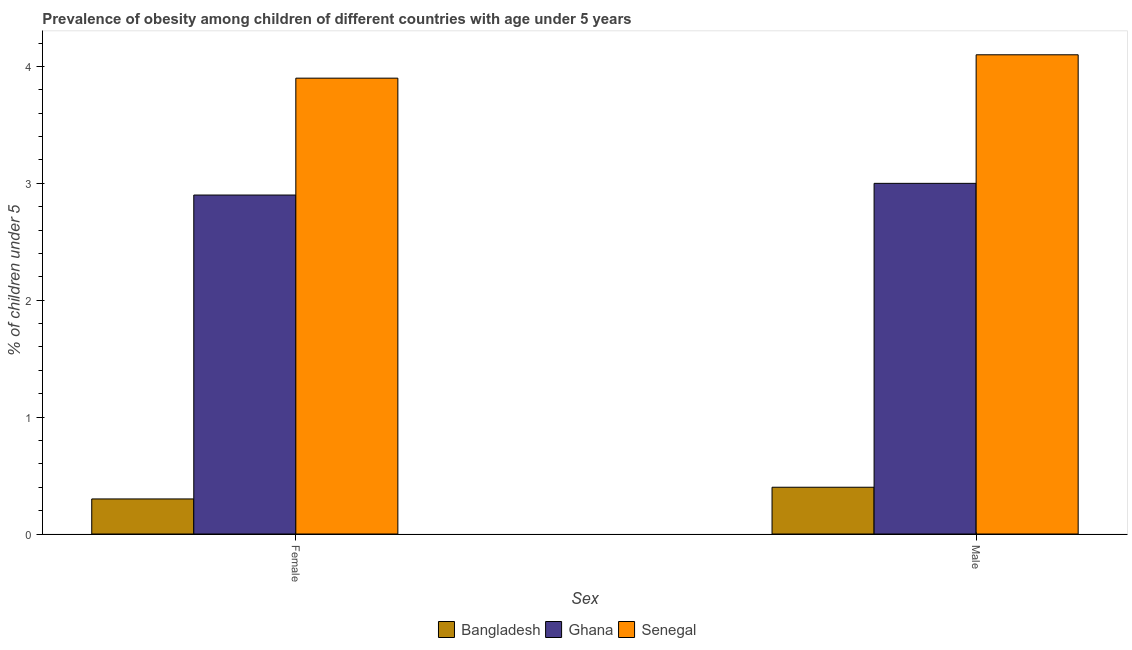How many groups of bars are there?
Offer a terse response. 2. Are the number of bars per tick equal to the number of legend labels?
Your answer should be compact. Yes. How many bars are there on the 1st tick from the right?
Offer a terse response. 3. What is the label of the 1st group of bars from the left?
Your response must be concise. Female. What is the percentage of obese male children in Bangladesh?
Your answer should be compact. 0.4. Across all countries, what is the maximum percentage of obese female children?
Provide a succinct answer. 3.9. Across all countries, what is the minimum percentage of obese female children?
Your answer should be very brief. 0.3. In which country was the percentage of obese female children maximum?
Provide a short and direct response. Senegal. What is the total percentage of obese male children in the graph?
Ensure brevity in your answer.  7.5. What is the difference between the percentage of obese male children in Bangladesh and that in Ghana?
Provide a short and direct response. -2.6. What is the difference between the percentage of obese female children in Bangladesh and the percentage of obese male children in Senegal?
Your response must be concise. -3.8. What is the average percentage of obese female children per country?
Offer a very short reply. 2.37. What is the difference between the percentage of obese male children and percentage of obese female children in Ghana?
Your answer should be very brief. 0.1. What is the ratio of the percentage of obese male children in Bangladesh to that in Senegal?
Give a very brief answer. 0.1. Is the percentage of obese male children in Bangladesh less than that in Ghana?
Make the answer very short. Yes. What does the 1st bar from the left in Male represents?
Provide a succinct answer. Bangladesh. What does the 2nd bar from the right in Male represents?
Your response must be concise. Ghana. How many bars are there?
Ensure brevity in your answer.  6. Are all the bars in the graph horizontal?
Provide a short and direct response. No. What is the difference between two consecutive major ticks on the Y-axis?
Your answer should be compact. 1. Does the graph contain any zero values?
Ensure brevity in your answer.  No. Does the graph contain grids?
Offer a terse response. No. Where does the legend appear in the graph?
Your response must be concise. Bottom center. How many legend labels are there?
Keep it short and to the point. 3. What is the title of the graph?
Give a very brief answer. Prevalence of obesity among children of different countries with age under 5 years. Does "Burkina Faso" appear as one of the legend labels in the graph?
Provide a succinct answer. No. What is the label or title of the X-axis?
Give a very brief answer. Sex. What is the label or title of the Y-axis?
Provide a succinct answer.  % of children under 5. What is the  % of children under 5 of Bangladesh in Female?
Ensure brevity in your answer.  0.3. What is the  % of children under 5 of Ghana in Female?
Your answer should be compact. 2.9. What is the  % of children under 5 of Senegal in Female?
Make the answer very short. 3.9. What is the  % of children under 5 of Bangladesh in Male?
Your answer should be compact. 0.4. What is the  % of children under 5 of Ghana in Male?
Offer a very short reply. 3. What is the  % of children under 5 of Senegal in Male?
Your answer should be compact. 4.1. Across all Sex, what is the maximum  % of children under 5 of Bangladesh?
Your answer should be very brief. 0.4. Across all Sex, what is the maximum  % of children under 5 in Ghana?
Ensure brevity in your answer.  3. Across all Sex, what is the maximum  % of children under 5 of Senegal?
Give a very brief answer. 4.1. Across all Sex, what is the minimum  % of children under 5 of Bangladesh?
Offer a terse response. 0.3. Across all Sex, what is the minimum  % of children under 5 in Ghana?
Your response must be concise. 2.9. Across all Sex, what is the minimum  % of children under 5 in Senegal?
Your answer should be compact. 3.9. What is the total  % of children under 5 in Bangladesh in the graph?
Your answer should be very brief. 0.7. What is the total  % of children under 5 in Ghana in the graph?
Provide a short and direct response. 5.9. What is the difference between the  % of children under 5 of Bangladesh in Female and that in Male?
Offer a terse response. -0.1. What is the difference between the  % of children under 5 of Ghana in Female and the  % of children under 5 of Senegal in Male?
Give a very brief answer. -1.2. What is the average  % of children under 5 in Ghana per Sex?
Your answer should be compact. 2.95. What is the difference between the  % of children under 5 of Ghana and  % of children under 5 of Senegal in Female?
Provide a succinct answer. -1. What is the difference between the  % of children under 5 of Bangladesh and  % of children under 5 of Senegal in Male?
Keep it short and to the point. -3.7. What is the ratio of the  % of children under 5 of Ghana in Female to that in Male?
Offer a very short reply. 0.97. What is the ratio of the  % of children under 5 of Senegal in Female to that in Male?
Offer a very short reply. 0.95. What is the difference between the highest and the second highest  % of children under 5 of Ghana?
Keep it short and to the point. 0.1. What is the difference between the highest and the lowest  % of children under 5 in Senegal?
Your answer should be very brief. 0.2. 